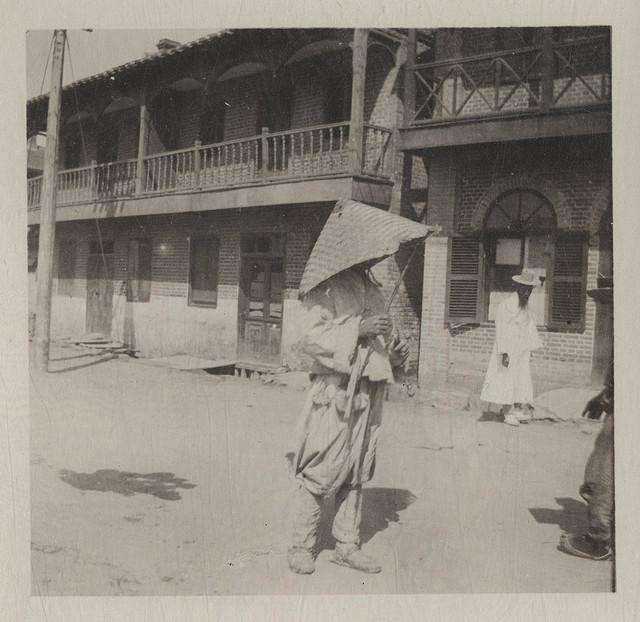How many people can be seen?
Concise answer only. 3. Is he wearing a hat?
Quick response, please. Yes. Is this picture in color?
Answer briefly. No. 